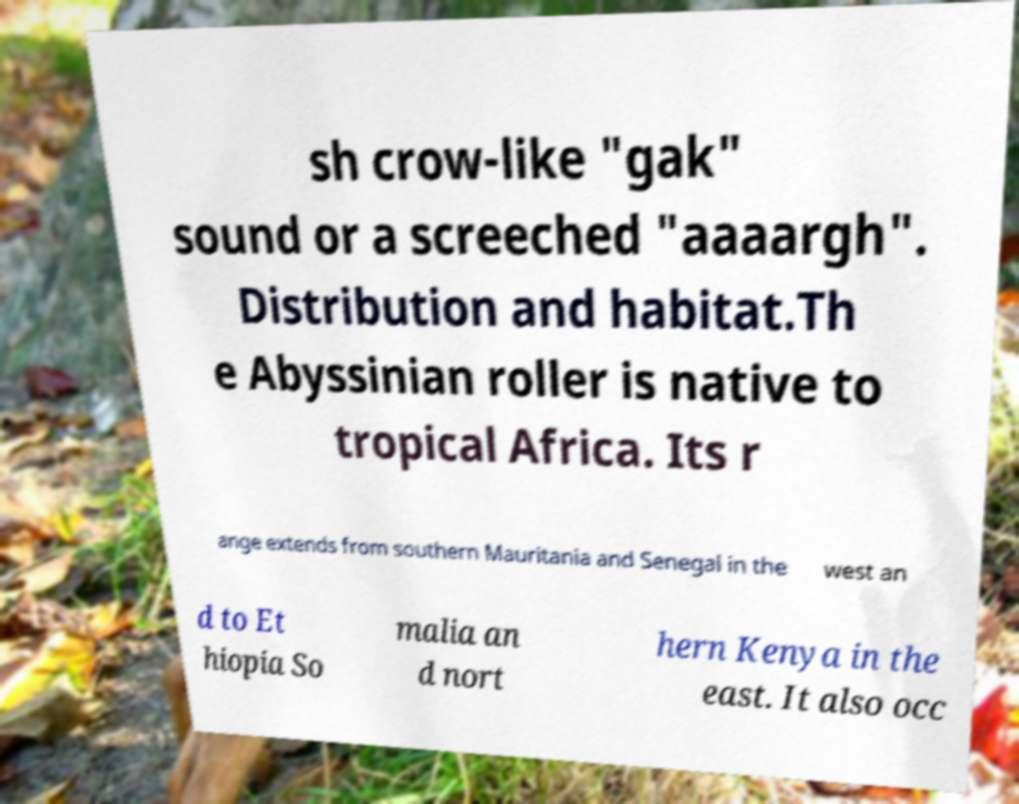Could you extract and type out the text from this image? sh crow-like "gak" sound or a screeched "aaaargh". Distribution and habitat.Th e Abyssinian roller is native to tropical Africa. Its r ange extends from southern Mauritania and Senegal in the west an d to Et hiopia So malia an d nort hern Kenya in the east. It also occ 